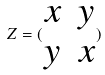<formula> <loc_0><loc_0><loc_500><loc_500>Z = ( \begin{matrix} x & y \\ y & x \end{matrix} )</formula> 